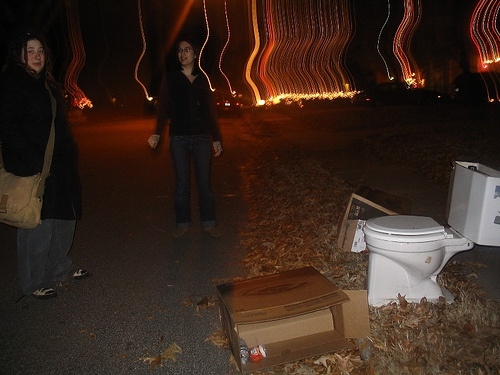Describe the objects in this image and their specific colors. I can see people in black, maroon, and gray tones, toilet in black, darkgray, gray, and lightgray tones, people in black, maroon, and brown tones, and handbag in black, maroon, and gray tones in this image. 